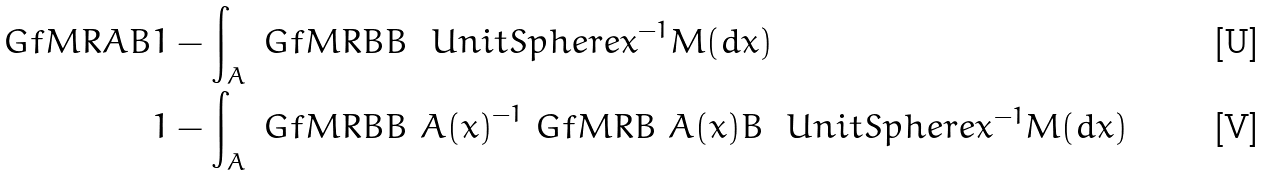Convert formula to latex. <formula><loc_0><loc_0><loc_500><loc_500>\ G f M R { A } { B } & 1 - \int _ { A } \ G f M R { B } { B \ \ U n i t S p h e r e { x } } ^ { - 1 } M ( d x ) \\ & 1 - \int _ { A } \ G f M R { B } { B \ A ( x ) } ^ { - 1 } \ G f M R { B \ A ( x ) } { B \ \ U n i t S p h e r e { x } } ^ { - 1 } M ( d x )</formula> 